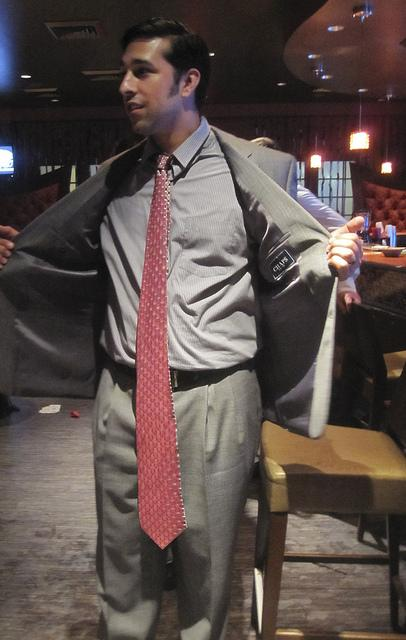What clothing item is most strangely fitting on this man?

Choices:
A) necktie
B) belt
C) shirt
D) pants necktie 